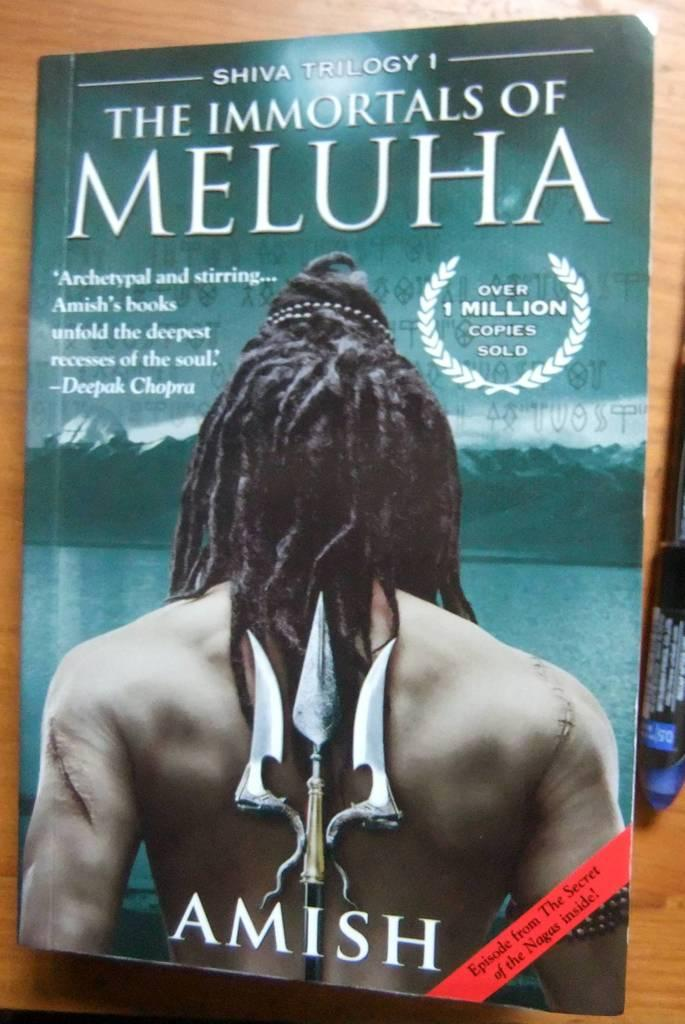<image>
Create a compact narrative representing the image presented. The book The Immortals of Meluha is on a wooden table. 